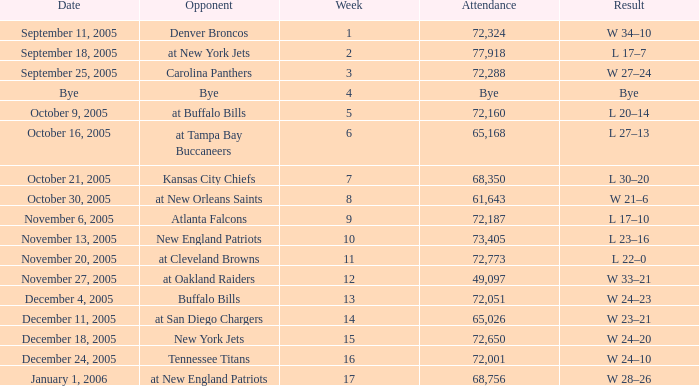On what Date was the Attendance 73,405? November 13, 2005. I'm looking to parse the entire table for insights. Could you assist me with that? {'header': ['Date', 'Opponent', 'Week', 'Attendance', 'Result'], 'rows': [['September 11, 2005', 'Denver Broncos', '1', '72,324', 'W 34–10'], ['September 18, 2005', 'at New York Jets', '2', '77,918', 'L 17–7'], ['September 25, 2005', 'Carolina Panthers', '3', '72,288', 'W 27–24'], ['Bye', 'Bye', '4', 'Bye', 'Bye'], ['October 9, 2005', 'at Buffalo Bills', '5', '72,160', 'L 20–14'], ['October 16, 2005', 'at Tampa Bay Buccaneers', '6', '65,168', 'L 27–13'], ['October 21, 2005', 'Kansas City Chiefs', '7', '68,350', 'L 30–20'], ['October 30, 2005', 'at New Orleans Saints', '8', '61,643', 'W 21–6'], ['November 6, 2005', 'Atlanta Falcons', '9', '72,187', 'L 17–10'], ['November 13, 2005', 'New England Patriots', '10', '73,405', 'L 23–16'], ['November 20, 2005', 'at Cleveland Browns', '11', '72,773', 'L 22–0'], ['November 27, 2005', 'at Oakland Raiders', '12', '49,097', 'W 33–21'], ['December 4, 2005', 'Buffalo Bills', '13', '72,051', 'W 24–23'], ['December 11, 2005', 'at San Diego Chargers', '14', '65,026', 'W 23–21'], ['December 18, 2005', 'New York Jets', '15', '72,650', 'W 24–20'], ['December 24, 2005', 'Tennessee Titans', '16', '72,001', 'W 24–10'], ['January 1, 2006', 'at New England Patriots', '17', '68,756', 'W 28–26']]} 